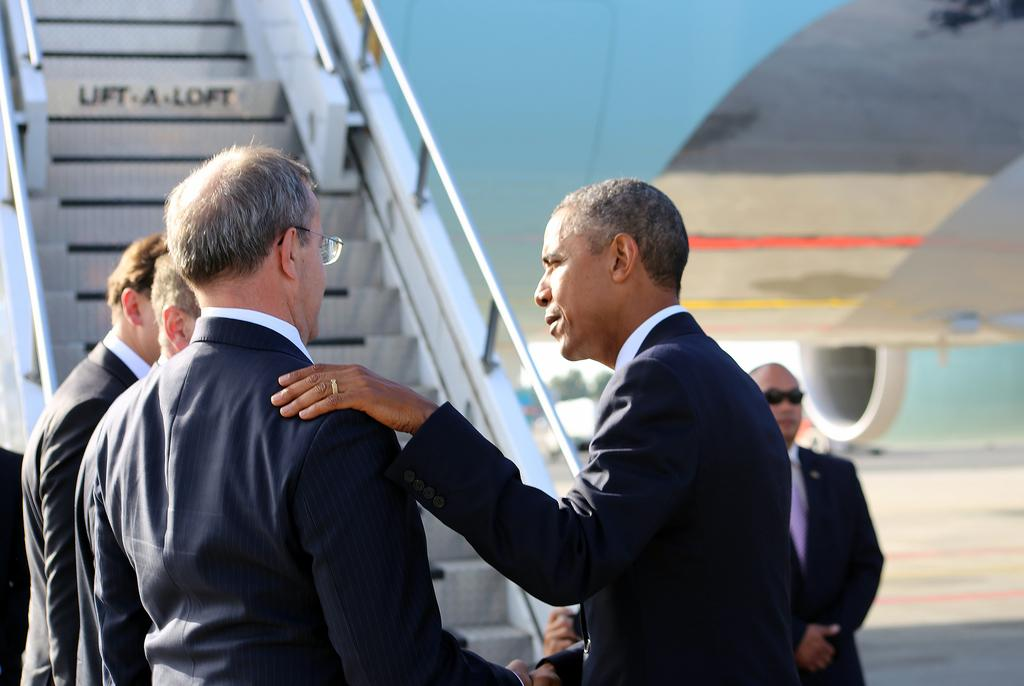How many people are in the image? There are people in the image, but the exact number is not specified. What are the people in the image doing? The people in the image are standing. Can you describe any specific features of the people in the image? Some people in the image are wearing spectacles. What else can be seen in the image besides the people? There is an airplane in the image. What type of lumber is being used to build the airplane in the image? There is no mention of lumber or any construction process in the image. The airplane is already built and visible in the image. --- 